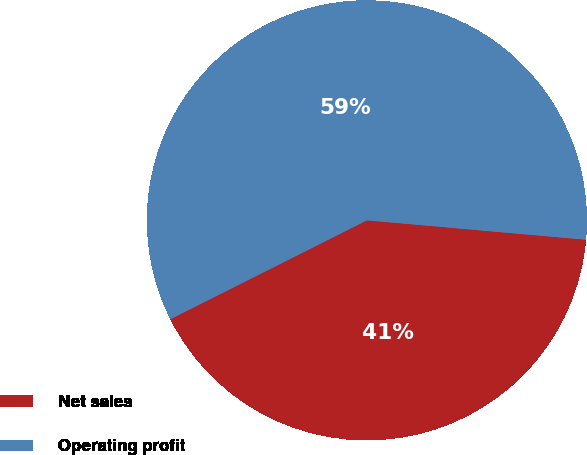<chart> <loc_0><loc_0><loc_500><loc_500><pie_chart><fcel>Net sales<fcel>Operating profit<nl><fcel>41.18%<fcel>58.82%<nl></chart> 